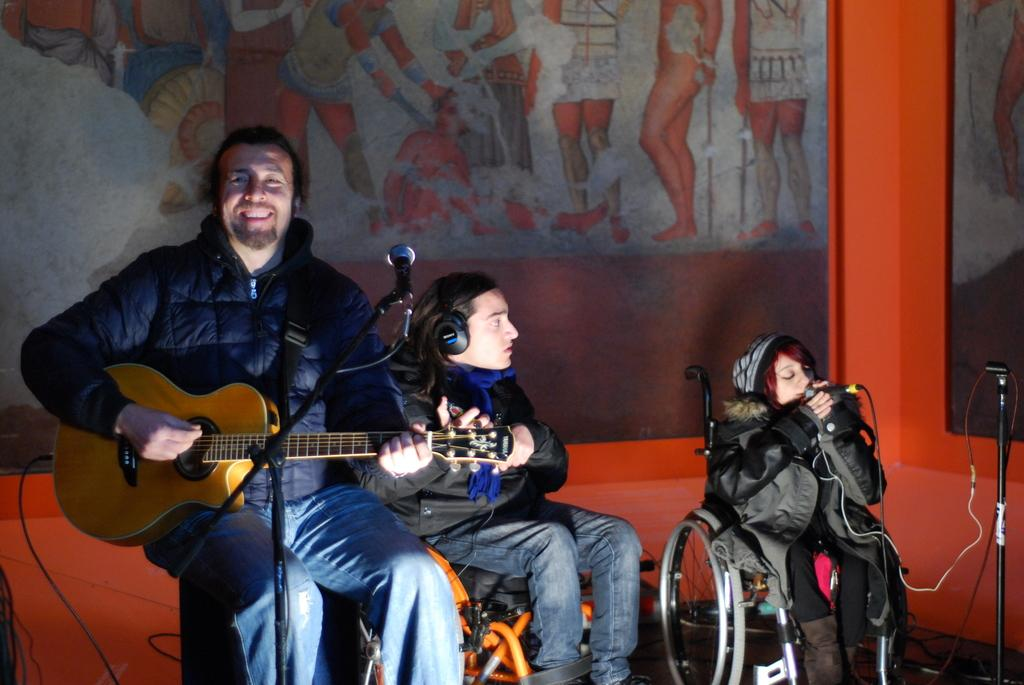How many people are in the image? There are three people in the image. What are the people doing in the image? The people are holding musical instruments. What are the people wearing in the image? The people are wearing black jackets. How many boys are laughing in the image? There is no information about boys or laughter in the image; it only shows three people holding musical instruments and wearing black jackets. 